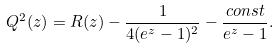<formula> <loc_0><loc_0><loc_500><loc_500>Q ^ { 2 } ( z ) = R ( z ) - \frac { 1 } { 4 ( e ^ { z } - 1 ) ^ { 2 } } - \frac { c o n s t } { e ^ { z } - 1 } .</formula> 